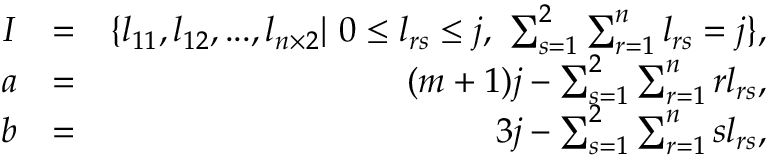<formula> <loc_0><loc_0><loc_500><loc_500>\begin{array} { r l r } { I } & { = } & { \{ l _ { 1 1 } , l _ { 1 2 } , \dots , l _ { n \times 2 } | 0 \leq l _ { r s } \leq j , \sum _ { s = 1 } ^ { 2 } \sum _ { r = 1 } ^ { n } l _ { r s } = j \} , } \\ { a } & { = } & { ( m + 1 ) j - \sum _ { s = 1 } ^ { 2 } \sum _ { r = 1 } ^ { n } r l _ { r s } , } \\ { b } & { = } & { 3 j - \sum _ { s = 1 } ^ { 2 } \sum _ { r = 1 } ^ { n } s l _ { r s } , } \end{array}</formula> 